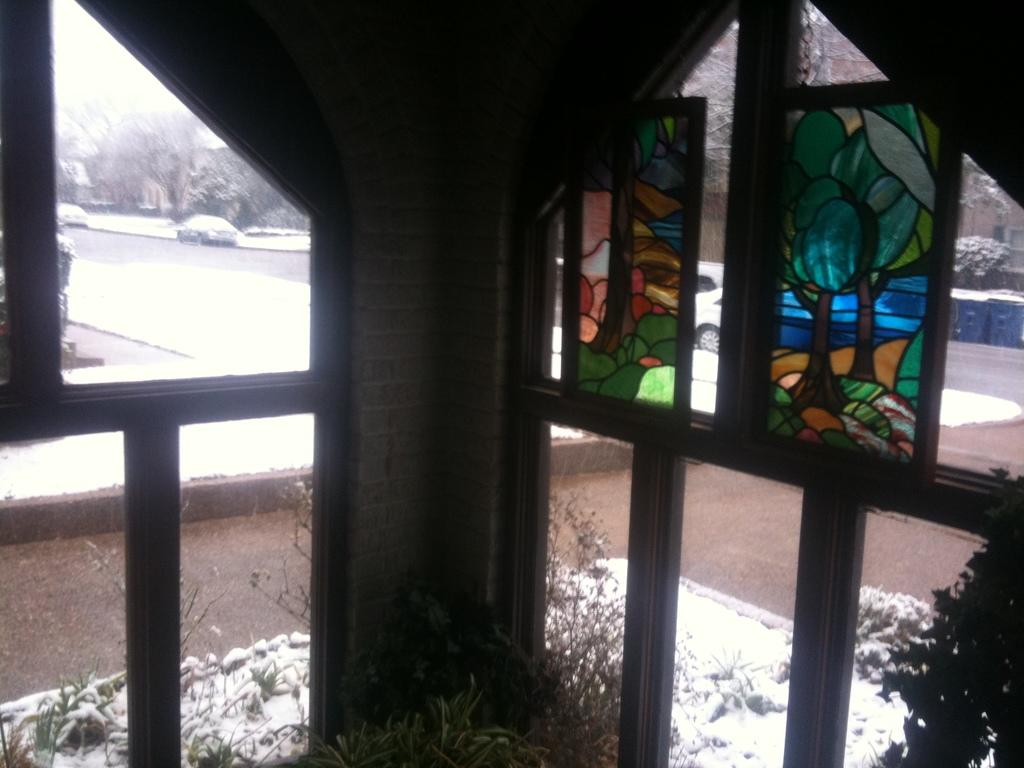What type of openings can be seen in the image? There are windows in the image. What type of living organisms are present in the image? There are plants and trees visible in the image. What can be used for walking or traveling in the image? There is a pathway in the image. What type of stem can be seen growing from the plants in the image? There is no specific stem mentioned in the image, as it only states that there are plants and trees present. What type of beast is visible in the image? There are no beasts present in the image; it features windows, plants, trees, and a pathway. 